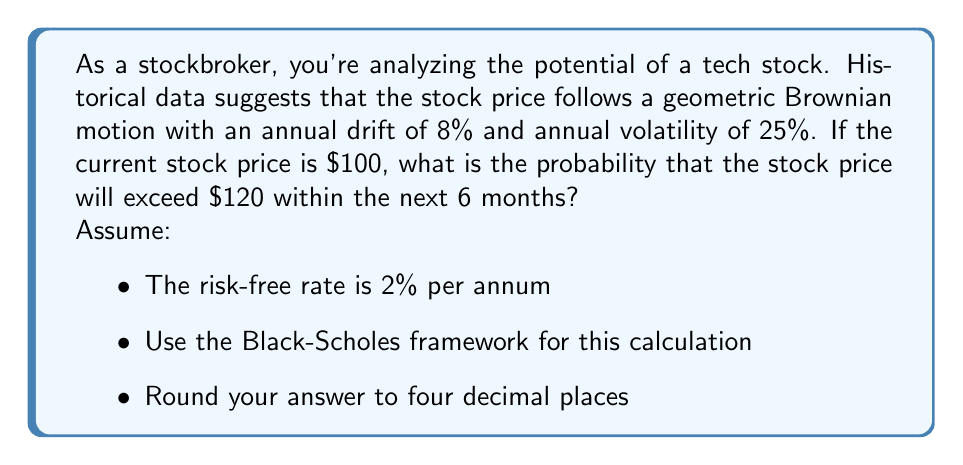Solve this math problem. To solve this problem, we'll use the Black-Scholes framework and treat the threshold as a call option. We need to calculate the probability that the stock price will be above $120 at the end of 6 months.

Step 1: Calculate the inputs for the Black-Scholes formula
- Current stock price (S) = $100
- Strike price (K) = $120
- Time to expiration (T) = 0.5 years (6 months)
- Risk-free rate (r) = 2% = 0.02
- Volatility (σ) = 25% = 0.25

Step 2: Calculate d1 and d2
$$d_1 = \frac{\ln(S/K) + (r + \sigma^2/2)T}{\sigma\sqrt{T}}$$
$$d_2 = d_1 - \sigma\sqrt{T}$$

Plugging in the values:
$$d_1 = \frac{\ln(100/120) + (0.02 + 0.25^2/2) * 0.5}{0.25\sqrt{0.5}} = -0.5097$$
$$d_2 = -0.5097 - 0.25\sqrt{0.5} = -0.6864$$

Step 3: Calculate the probability
The probability that the stock price will exceed $120 at the end of 6 months is equal to N(d2), where N() is the cumulative standard normal distribution function.

$$P(S_T > 120) = N(d_2) = N(-0.6864)$$

Using a standard normal distribution table or calculator:
$$N(-0.6864) = 0.2462$$

Therefore, the probability that the stock price will exceed $120 within the next 6 months is approximately 0.2462 or 24.62%.
Answer: 0.2462 